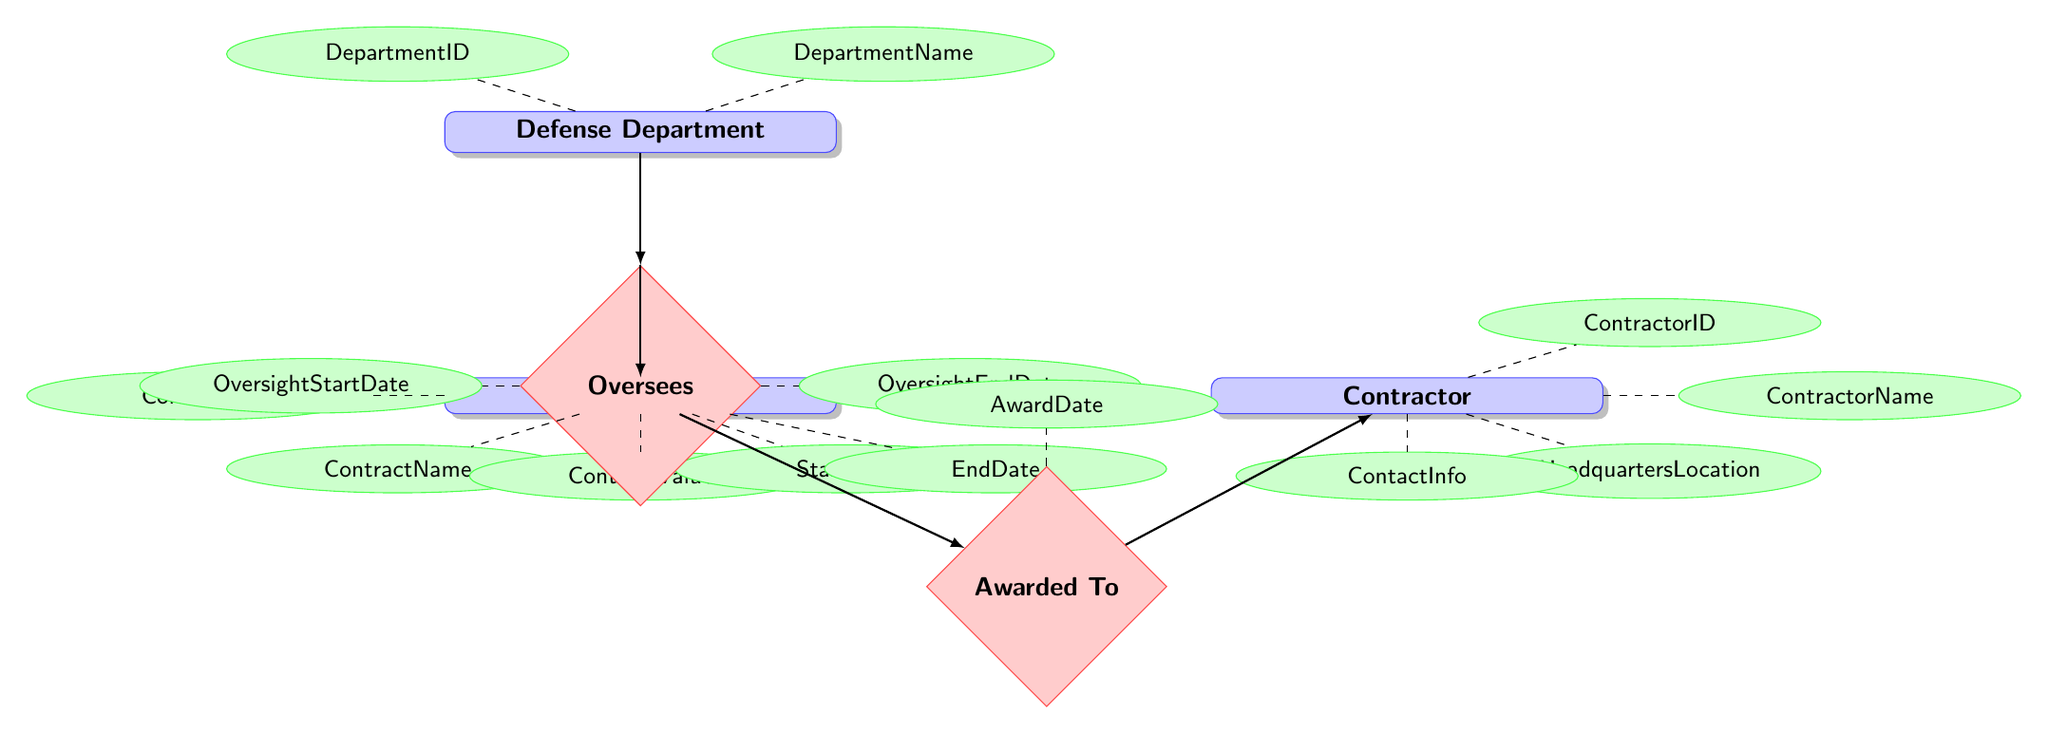What entities are included in the diagram? The entities present in the diagram are listed directly within the "entities" section. The entities are: Defense Department, Contract, and Contractor.
Answer: Defense Department, Contract, Contractor How many attributes does the Contractor entity have? By checking the attributes listed for the Contractor entity, we find there are four attributes: ContractorID, ContractorName, HeadquartersLocation, and ContactInfo.
Answer: 4 What is the relationship between the Defense Department and the Contract? The relationship is defined as "Oversees," which connects the Defense Department directly to the Contract.
Answer: Oversees What attribute does the Awarded To relationship have? Within the diagram, the Awarded To relationship has one attribute listed as AwardDate.
Answer: AwardDate How many relationships exist between the entities depicted in the diagram? The diagram specifies two relationships present: "Oversees" and "Awarded To." This indicates a total of two relationships connecting the entities.
Answer: 2 What is the primary focus of the relationship that connects a Contract to a Contractor? The primary focus of the connection between Contract and Contractor is described as "Awarded To." This captures the essence of contractual relationships in defense contracting.
Answer: Awarded To What attributes are associated with the oversees relationship? The attributes associated with the oversees relationship include OversightStartDate and OversightEndDate, which provide context about the oversight period.
Answer: OversightStartDate, OversightEndDate What do the attributes of the Contract entity indicate? The attributes of the Contract entity highlight specific details regarding contracts, including elements such as ContractID, ContractName, ContractValue, StartDate, and EndDate.
Answer: ContractID, ContractName, ContractValue, StartDate, EndDate Which entity is connected directly to the Contract entity? The entity connected directly to the Contract entity is the Contractor through the "Awarded To" relationship, highlighting the contractor who is granted the contract.
Answer: Contractor 